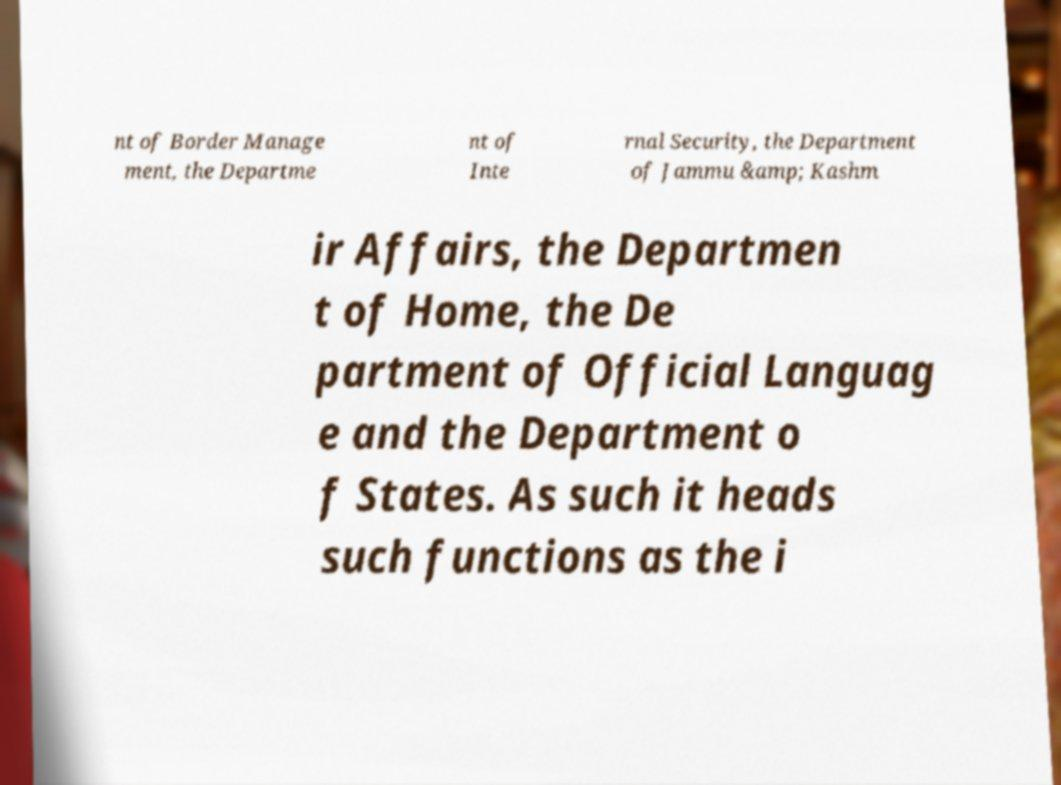What messages or text are displayed in this image? I need them in a readable, typed format. nt of Border Manage ment, the Departme nt of Inte rnal Security, the Department of Jammu &amp; Kashm ir Affairs, the Departmen t of Home, the De partment of Official Languag e and the Department o f States. As such it heads such functions as the i 